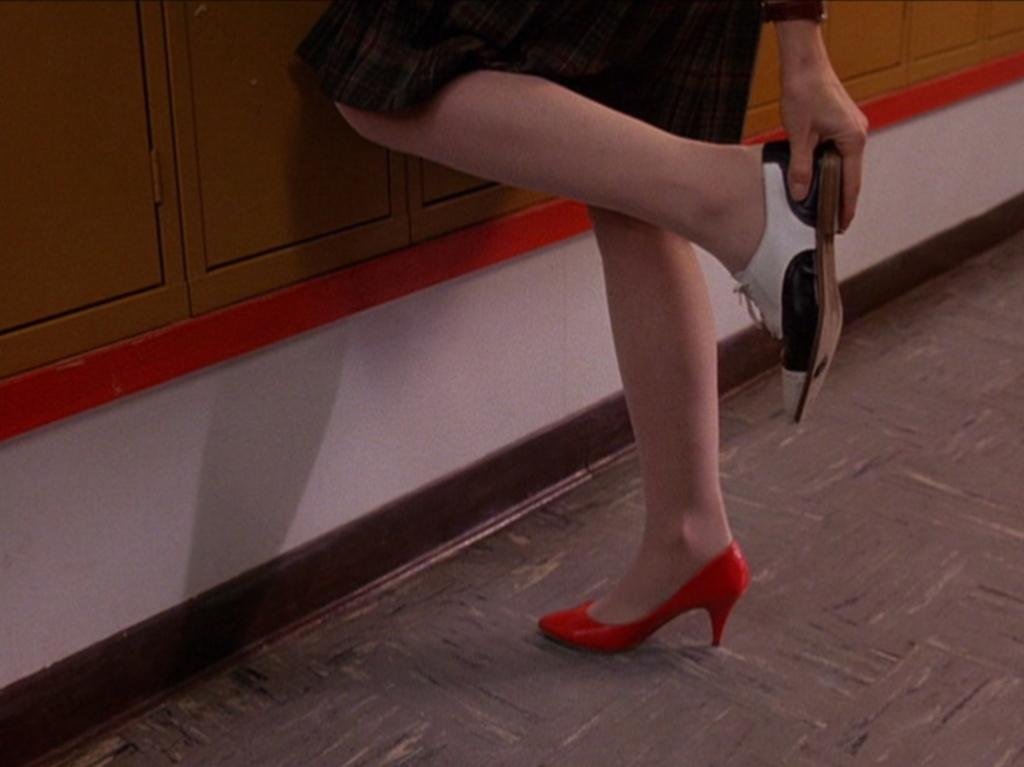What part of a person can be seen in the image? There are legs of a person visible in the image. What is the person holding in the image? The person is holding a shoe. What is the person's income in the image? There is no information about the person's income in the image. Can you describe the cellar in the image? There is no cellar present in the image. 